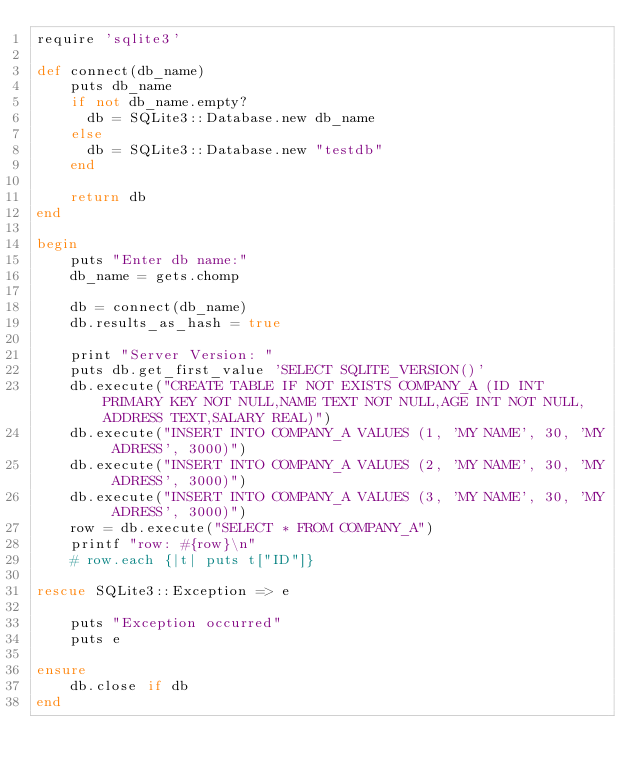<code> <loc_0><loc_0><loc_500><loc_500><_Ruby_>require 'sqlite3'

def connect(db_name)
    puts db_name
    if not db_name.empty?
      db = SQLite3::Database.new db_name
    else
      db = SQLite3::Database.new "testdb"
    end

    return db
end

begin
    puts "Enter db name:"
    db_name = gets.chomp

    db = connect(db_name)
    db.results_as_hash = true

    print "Server Version: "
    puts db.get_first_value 'SELECT SQLITE_VERSION()'
    db.execute("CREATE TABLE IF NOT EXISTS COMPANY_A (ID INT PRIMARY KEY NOT NULL,NAME TEXT NOT NULL,AGE INT NOT NULL,ADDRESS TEXT,SALARY REAL)")
    db.execute("INSERT INTO COMPANY_A VALUES (1, 'MY NAME', 30, 'MY ADRESS', 3000)")
    db.execute("INSERT INTO COMPANY_A VALUES (2, 'MY NAME', 30, 'MY ADRESS', 3000)")
    db.execute("INSERT INTO COMPANY_A VALUES (3, 'MY NAME', 30, 'MY ADRESS', 3000)")
    row = db.execute("SELECT * FROM COMPANY_A")
    printf "row: #{row}\n"
    # row.each {|t| puts t["ID"]}

rescue SQLite3::Exception => e 
    
    puts "Exception occurred"
    puts e
    
ensure
    db.close if db
end
</code> 